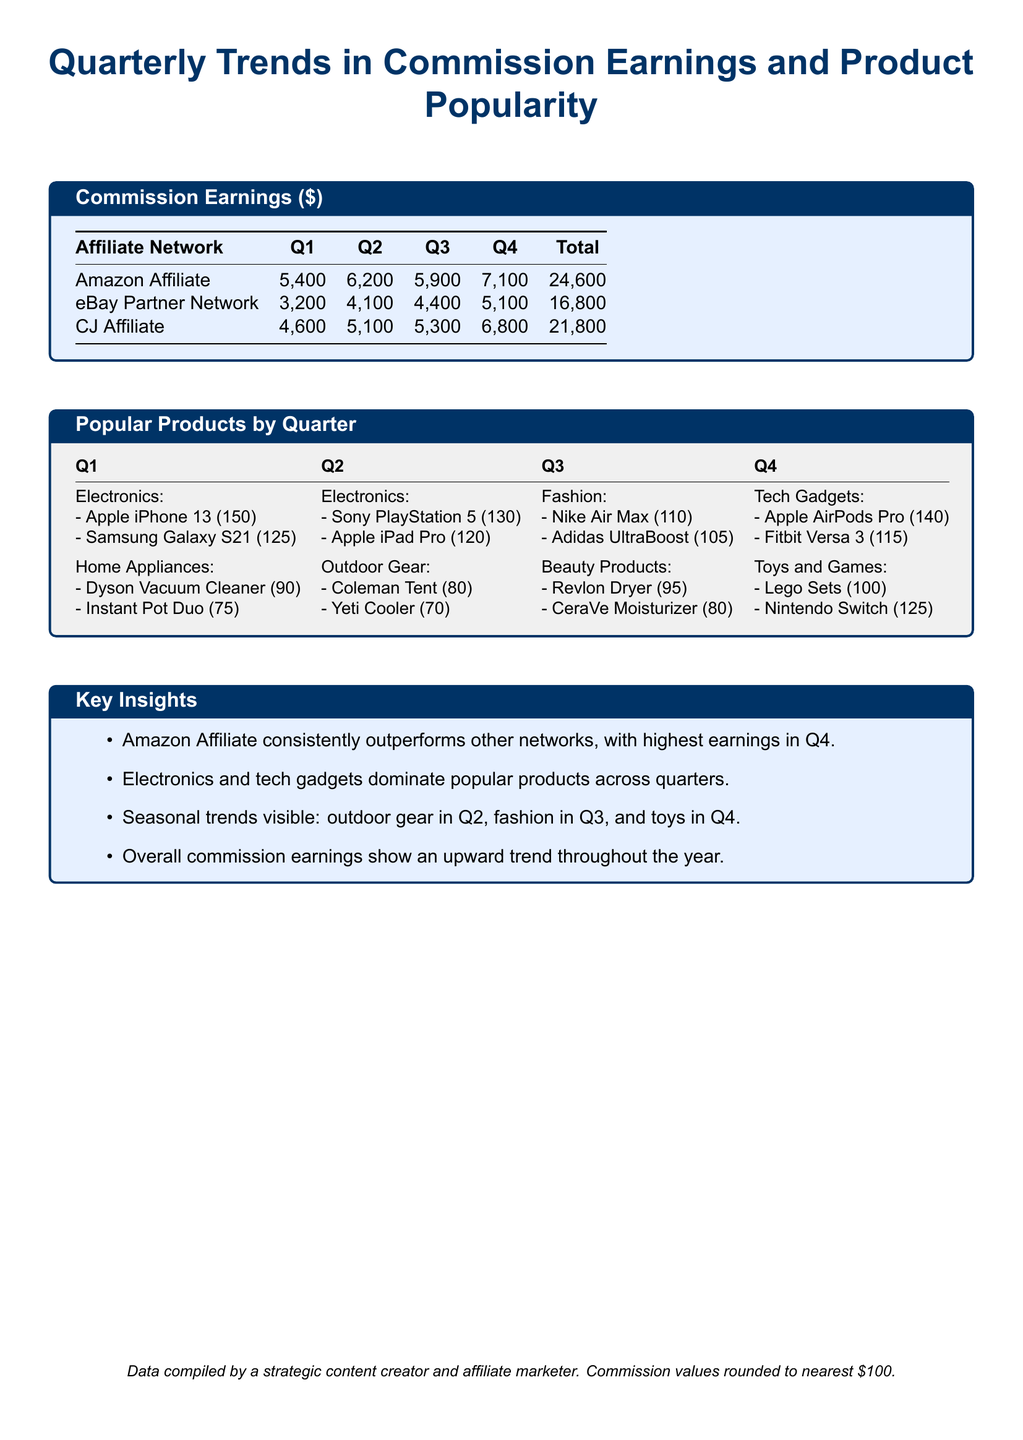What was the total commission earned by Amazon Affiliate? The total commission can be found in the table under Amazon Affiliate, which is $24,600.
Answer: $24,600 Which product was the most popular in Q2 and how many were sold? The most popular product in Q2 can be identified in the Popular Products section, which is the Sony PlayStation 5 with 130 sold.
Answer: Sony PlayStation 5 (130) What category of products was dominant in Q1? The category of products mentioned in Q1 highlights Electronics as the dominant category, with notable products listed.
Answer: Electronics Which network had the second highest earnings in Q4? By comparing the Q4 earnings, CJ Affiliate had the second highest earnings of $6,800.
Answer: CJ Affiliate What is the trend of overall commission earnings throughout the year? The Key Insights section indicates that overall commission earnings show an upward trend throughout the year.
Answer: Upward trend What type of products are popular in Q3? The Popular Products by Quarter section specifies Fashion products as predominant in Q3.
Answer: Fashion Which product category was highlighted for Q2? The document identifies Outdoor Gear as the highlighted category for Q2.
Answer: Outdoor Gear What was the total commission earned by CJ Affiliate? The total commission for CJ Affiliate can be found in the table, which is $21,800.
Answer: $21,800 What seasonal product trend is visible in Q4? The Key Insights section notes that Toys and Games are prominently featured in Q4.
Answer: Toys and Games 